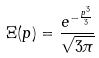<formula> <loc_0><loc_0><loc_500><loc_500>\Xi ( p ) = \frac { e ^ { - \frac { p ^ { 3 } } { 3 } } } { \sqrt { 3 \pi } }</formula> 